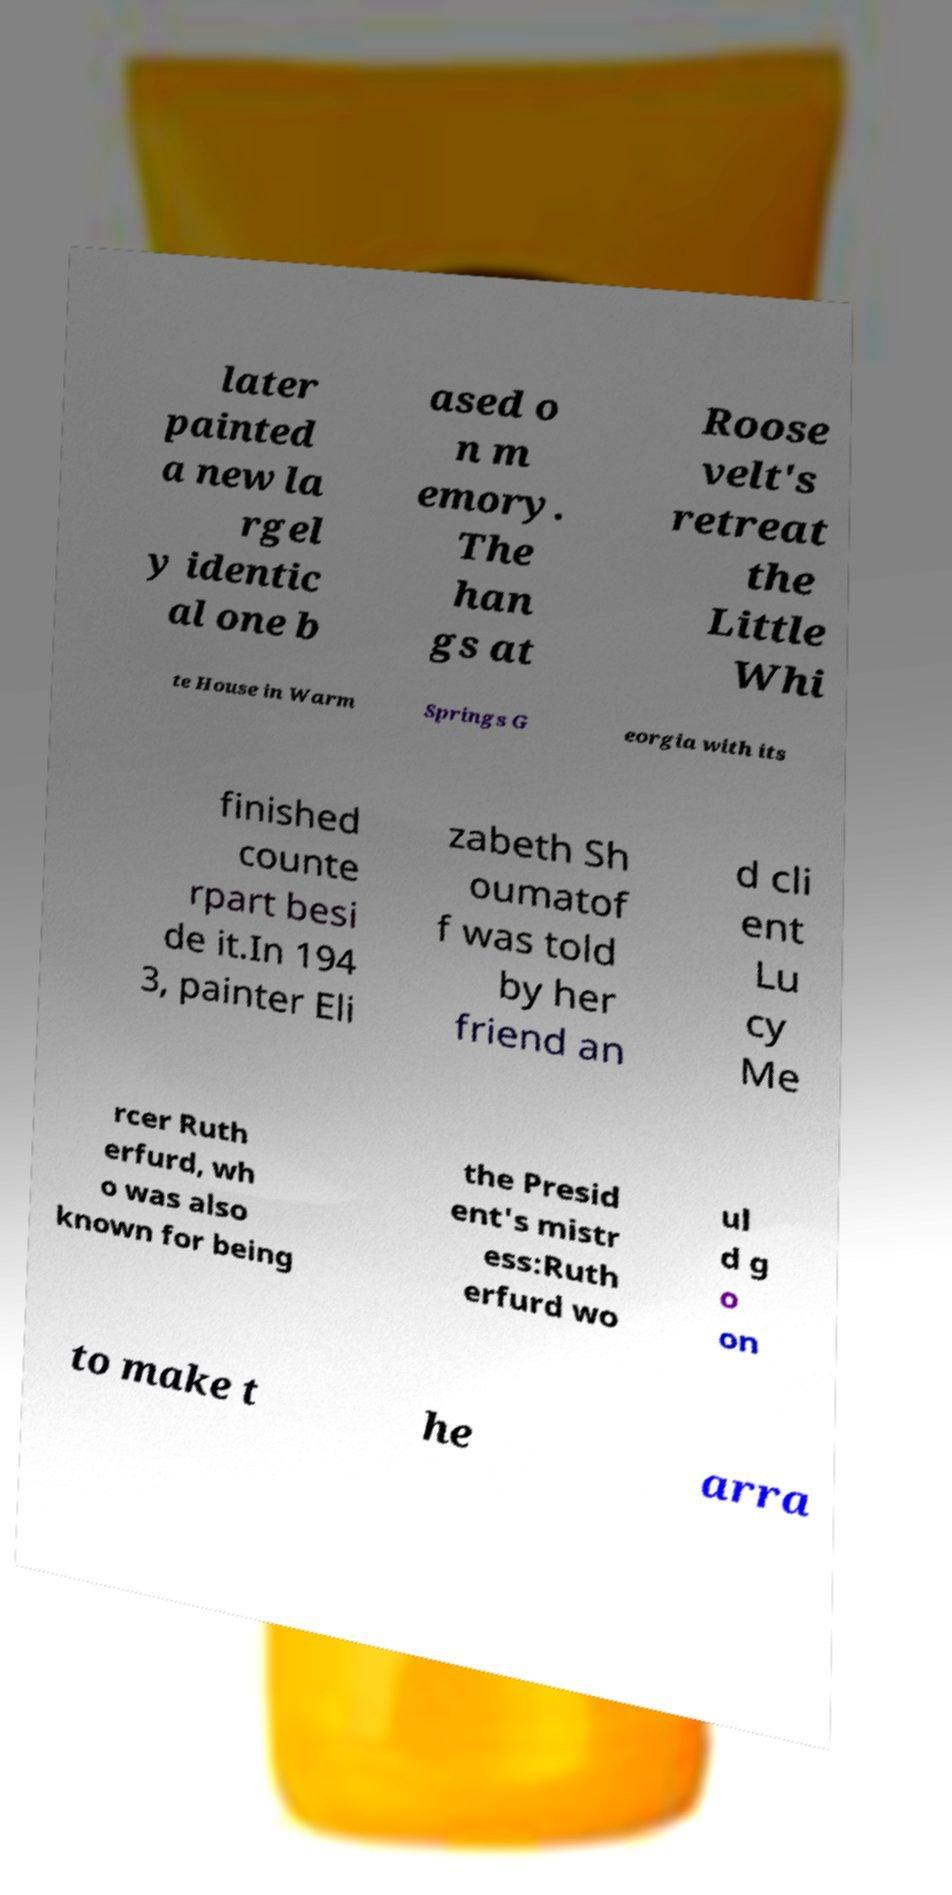Can you read and provide the text displayed in the image?This photo seems to have some interesting text. Can you extract and type it out for me? later painted a new la rgel y identic al one b ased o n m emory. The han gs at Roose velt's retreat the Little Whi te House in Warm Springs G eorgia with its finished counte rpart besi de it.In 194 3, painter Eli zabeth Sh oumatof f was told by her friend an d cli ent Lu cy Me rcer Ruth erfurd, wh o was also known for being the Presid ent's mistr ess:Ruth erfurd wo ul d g o on to make t he arra 